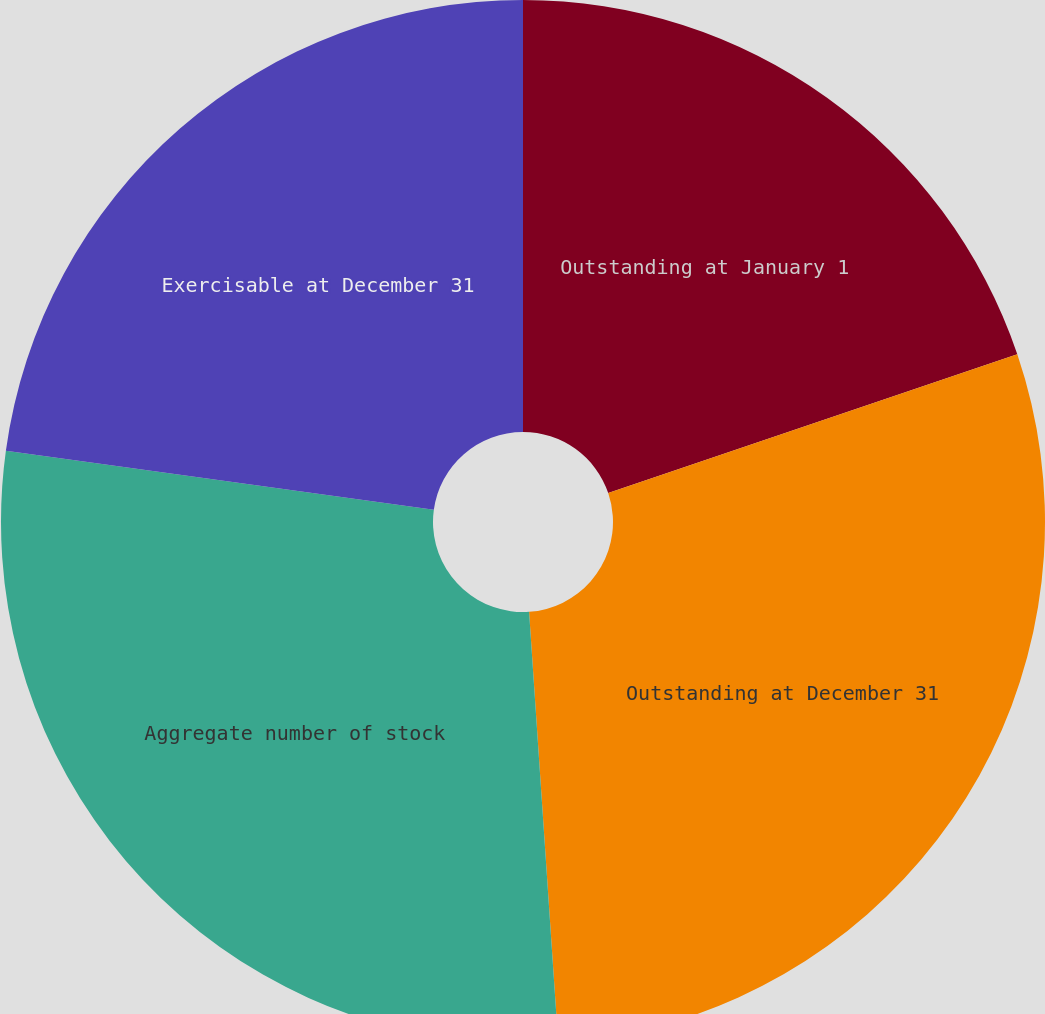<chart> <loc_0><loc_0><loc_500><loc_500><pie_chart><fcel>Outstanding at January 1<fcel>Outstanding at December 31<fcel>Aggregate number of stock<fcel>Exercisable at December 31<nl><fcel>19.79%<fcel>29.13%<fcel>28.25%<fcel>22.82%<nl></chart> 